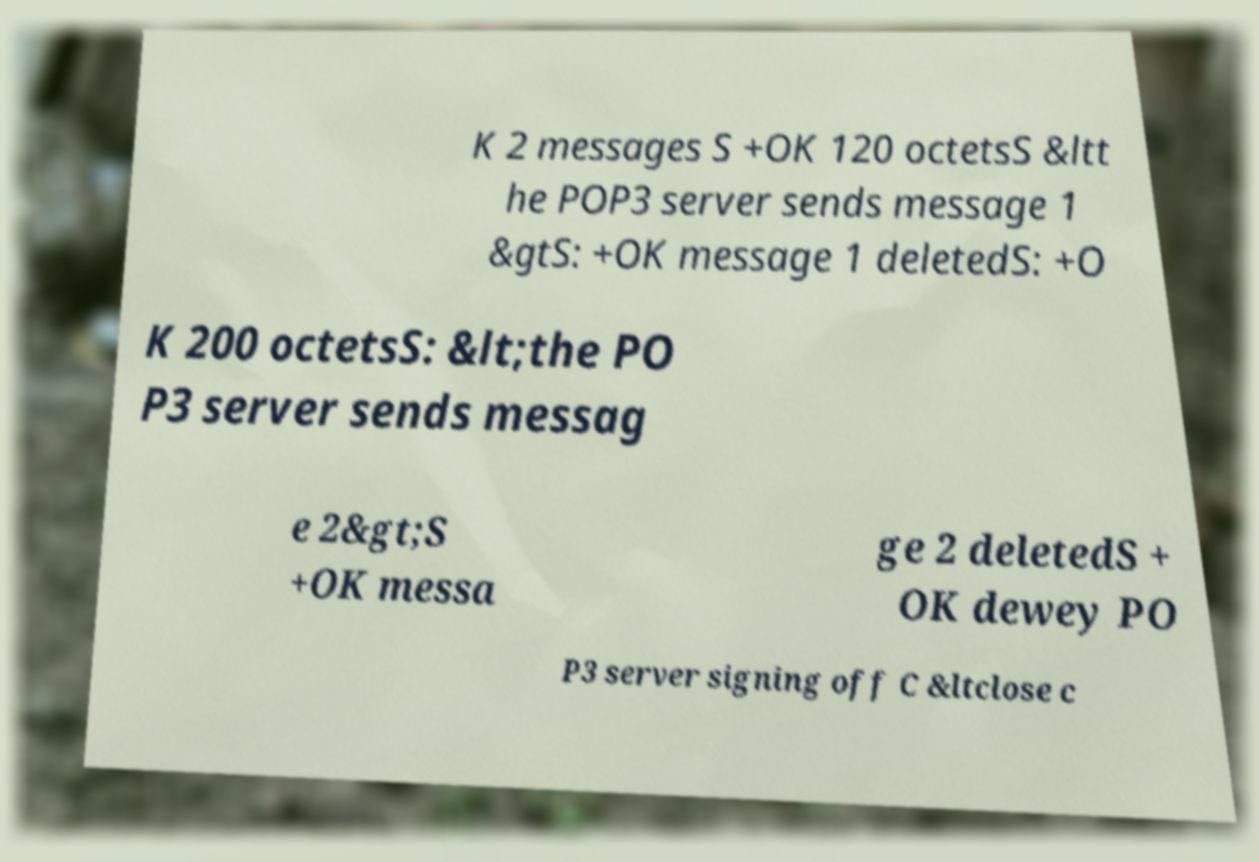Please identify and transcribe the text found in this image. K 2 messages S +OK 120 octetsS &ltt he POP3 server sends message 1 &gtS: +OK message 1 deletedS: +O K 200 octetsS: &lt;the PO P3 server sends messag e 2&gt;S +OK messa ge 2 deletedS + OK dewey PO P3 server signing off C &ltclose c 